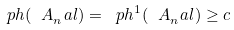Convert formula to latex. <formula><loc_0><loc_0><loc_500><loc_500>\ p h ( \ A _ { n } ^ { \ } a l ) = \ p h ^ { 1 } ( \ A _ { n } ^ { \ } a l ) \geq c</formula> 